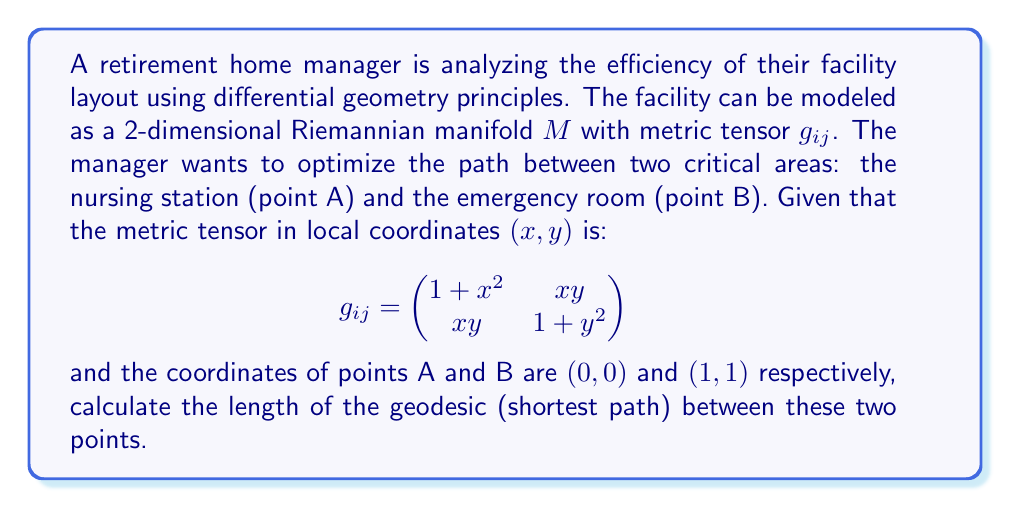What is the answer to this math problem? To solve this problem, we'll follow these steps:

1) The length of a curve $\gamma(t) = (x(t), y(t))$ on a Riemannian manifold is given by the integral:

   $$L = \int_0^1 \sqrt{g_{ij}\frac{d\gamma^i}{dt}\frac{d\gamma^j}{dt}}dt$$

2) For a geodesic, this length is minimized. The Euler-Lagrange equations for this variational problem lead to the geodesic equations:

   $$\frac{d^2x^k}{dt^2} + \Gamma^k_{ij}\frac{dx^i}{dt}\frac{dx^j}{dt} = 0$$

   where $\Gamma^k_{ij}$ are the Christoffel symbols.

3) Calculating the Christoffel symbols for our metric:

   $$\Gamma^1_{11} = x, \Gamma^1_{12} = \Gamma^1_{21} = \frac{y}{2}, \Gamma^1_{22} = -x$$
   $$\Gamma^2_{11} = -y, \Gamma^2_{12} = \Gamma^2_{21} = \frac{x}{2}, \Gamma^2_{22} = y$$

4) Substituting into the geodesic equations:

   $$\frac{d^2x}{dt^2} + x(\frac{dx}{dt})^2 + y\frac{dx}{dt}\frac{dy}{dt} - x(\frac{dy}{dt})^2 = 0$$
   $$\frac{d^2y}{dt^2} - y(\frac{dx}{dt})^2 + x\frac{dx}{dt}\frac{dy}{dt} + y(\frac{dy}{dt})^2 = 0$$

5) These equations are difficult to solve analytically. However, for small distances, we can approximate the geodesic by a straight line:

   $$x(t) = t, y(t) = t, 0 \leq t \leq 1$$

6) Substituting this into the length integral:

   $$L = \int_0^1 \sqrt{(1+t^2)(1)^2 + 2t^2(1)(1) + (1+t^2)(1)^2}dt$$
   $$= \int_0^1 \sqrt{2+4t^2}dt$$

7) This integral can be solved analytically:

   $$L = \frac{1}{4}[t\sqrt{2+4t^2} + \sqrt{2}\ln(t+\sqrt{\frac{1}{2}+t^2})]_0^1$$

8) Evaluating the limits:

   $$L = \frac{1}{4}[\sqrt{6} + \sqrt{2}\ln(1+\sqrt{\frac{3}{2}}) - 0 - \sqrt{2}\ln(\sqrt{\frac{1}{2}})]$$
Answer: The approximate length of the geodesic between points A and B is:

$$L = \frac{1}{4}[\sqrt{6} + \sqrt{2}\ln(1+\sqrt{\frac{3}{2}}) + \frac{\sqrt{2}}{2}\ln(2)] \approx 1.4728$$ 